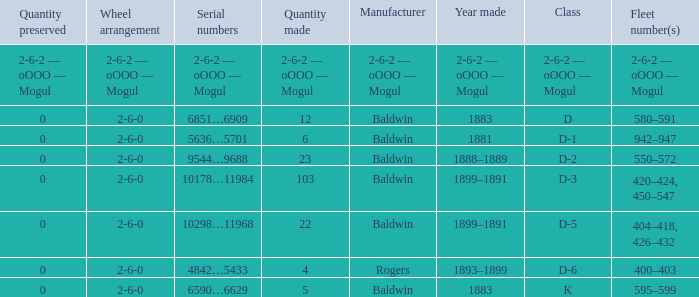Help me parse the entirety of this table. {'header': ['Quantity preserved', 'Wheel arrangement', 'Serial numbers', 'Quantity made', 'Manufacturer', 'Year made', 'Class', 'Fleet number(s)'], 'rows': [['2-6-2 — oOOO — Mogul', '2-6-2 — oOOO — Mogul', '2-6-2 — oOOO — Mogul', '2-6-2 — oOOO — Mogul', '2-6-2 — oOOO — Mogul', '2-6-2 — oOOO — Mogul', '2-6-2 — oOOO — Mogul', '2-6-2 — oOOO — Mogul'], ['0', '2-6-0', '6851…6909', '12', 'Baldwin', '1883', 'D', '580–591'], ['0', '2-6-0', '5636…5701', '6', 'Baldwin', '1881', 'D-1', '942–947'], ['0', '2-6-0', '9544…9688', '23', 'Baldwin', '1888–1889', 'D-2', '550–572'], ['0', '2-6-0', '10178…11984', '103', 'Baldwin', '1899–1891', 'D-3', '420–424, 450–547'], ['0', '2-6-0', '10298…11968', '22', 'Baldwin', '1899–1891', 'D-5', '404–418, 426–432'], ['0', '2-6-0', '4842…5433', '4', 'Rogers', '1893–1899', 'D-6', '400–403'], ['0', '2-6-0', '6590…6629', '5', 'Baldwin', '1883', 'K', '595–599']]} What is the quantity made when the class is d-2? 23.0. 